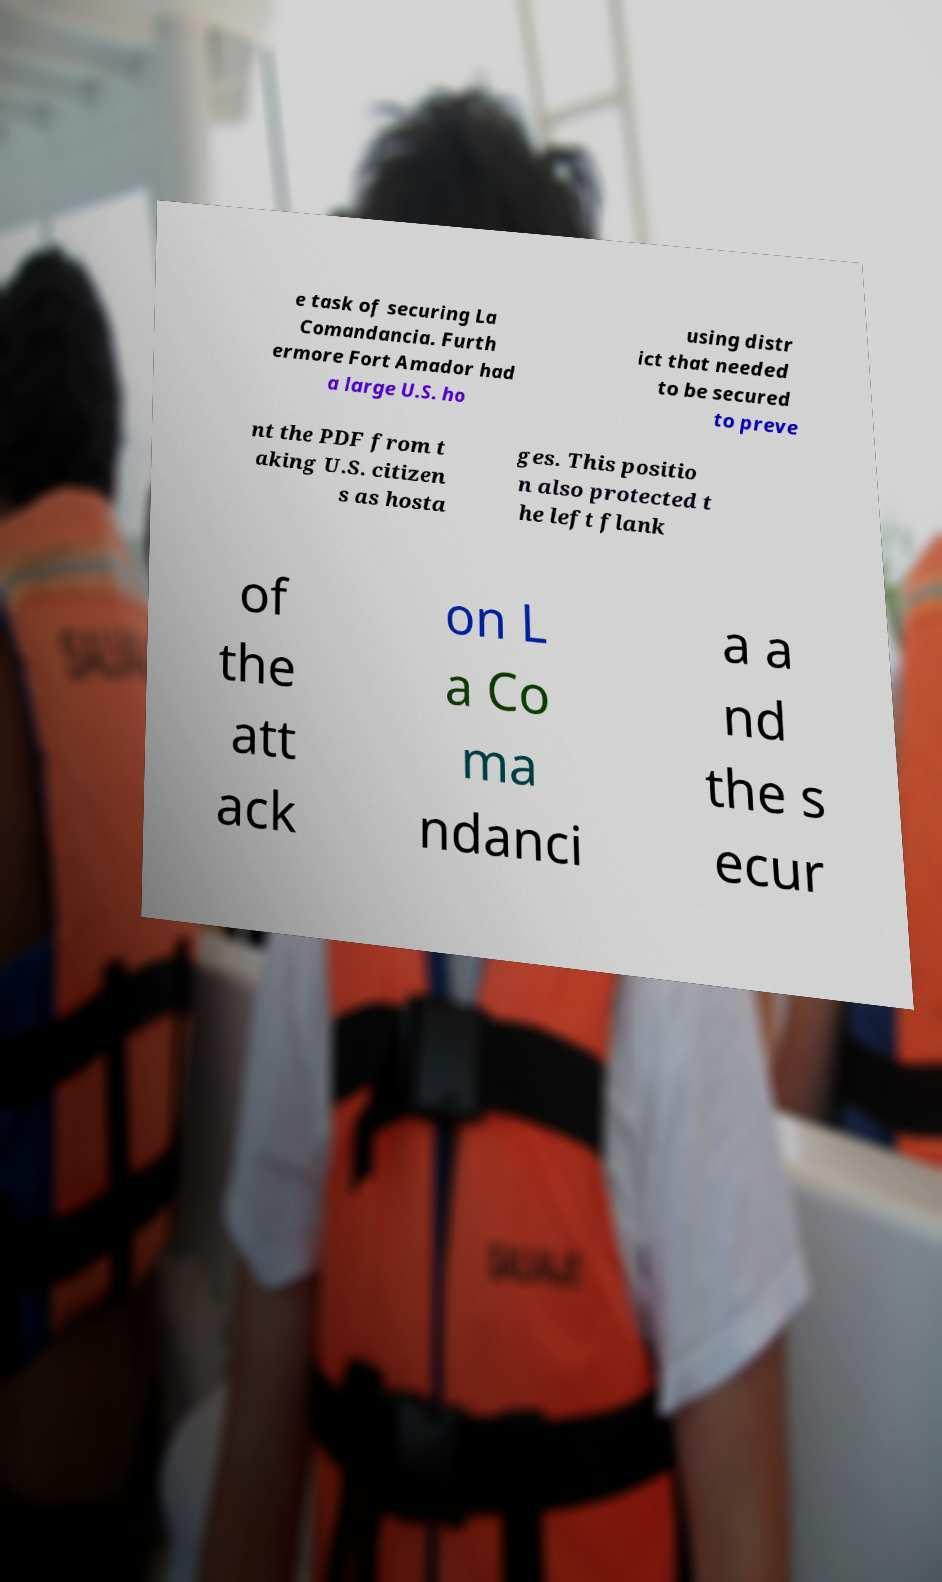Please read and relay the text visible in this image. What does it say? e task of securing La Comandancia. Furth ermore Fort Amador had a large U.S. ho using distr ict that needed to be secured to preve nt the PDF from t aking U.S. citizen s as hosta ges. This positio n also protected t he left flank of the att ack on L a Co ma ndanci a a nd the s ecur 